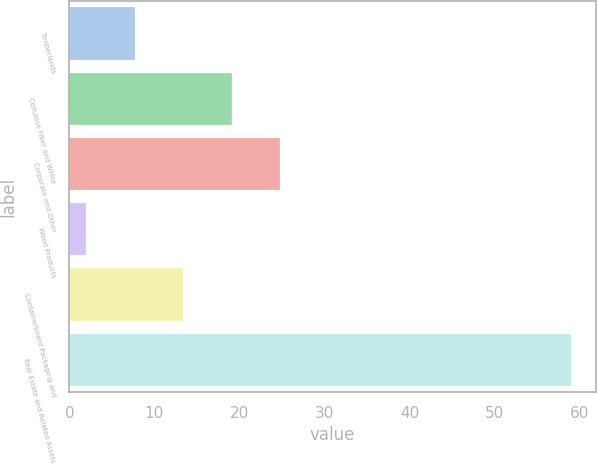Convert chart. <chart><loc_0><loc_0><loc_500><loc_500><bar_chart><fcel>Timberlands<fcel>Cellulose Fiber and White<fcel>Corporate and Other<fcel>Wood Products<fcel>Containerboard Packaging and<fcel>Real Estate and Related Assets<nl><fcel>7.7<fcel>19.1<fcel>24.8<fcel>2<fcel>13.4<fcel>59<nl></chart> 